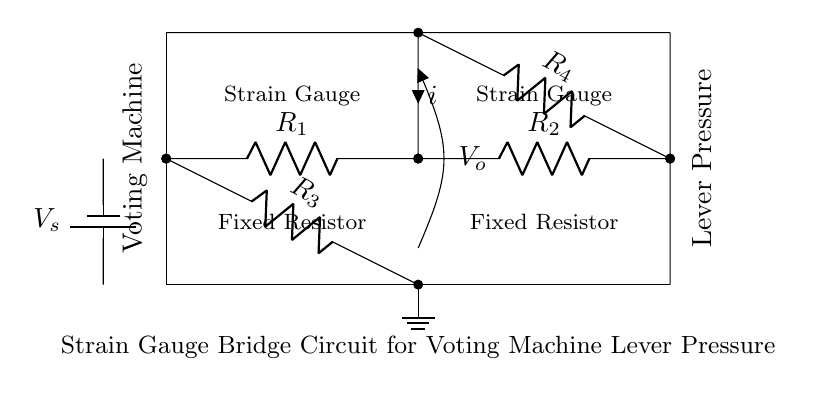What is the power supply voltage? The power supply voltage in this circuit diagram is labeled as V_s, and it is represented by the battery symbol.
Answer: V_s What type of circuit is this? This circuit is a strain gauge bridge circuit, which is specifically designed to measure small changes in resistance caused by strain on the gauges.
Answer: Strain gauge bridge How many resistors are used in the circuit? There are four resistors (R1, R2, R3, and R4) present in the circuit, which are necessary for the bridge configuration.
Answer: Four What is the function of the strain gauges in this circuit? The strain gauges are used to detect changes in pressure applied to the voting machine lever, converting mechanical strain into a measurable electrical signal.
Answer: Measure pressure What is the current direction in the circuit? The current is denoted with the variable i, flowing from the battery through the resistors and to ground, indicating the flow's direction.
Answer: From battery to ground What happens when pressure is applied to the lever? When pressure is applied to the lever, the resistance of the strain gauges changes, which alters the output voltage V_o across the bridge, indicating the amount of pressure applied.
Answer: Changes V_o What is the role of the ground in this circuit? The ground in this circuit serves as a reference point for the voltage measurements and provides a return path for the current.
Answer: Reference point 